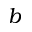<formula> <loc_0><loc_0><loc_500><loc_500>b</formula> 